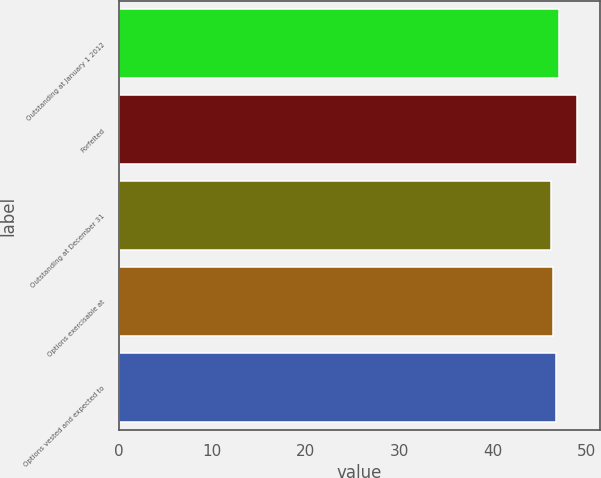Convert chart to OTSL. <chart><loc_0><loc_0><loc_500><loc_500><bar_chart><fcel>Outstanding at January 1 2012<fcel>Forfeited<fcel>Outstanding at December 31<fcel>Options exercisable at<fcel>Options vested and expected to<nl><fcel>47.06<fcel>49.02<fcel>46.22<fcel>46.5<fcel>46.78<nl></chart> 